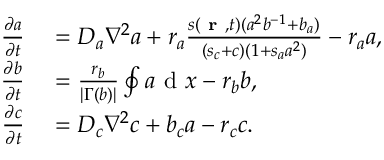<formula> <loc_0><loc_0><loc_500><loc_500>\begin{array} { r l } { \frac { \partial a } { \partial t } } & = D _ { a } \nabla ^ { 2 } a + r _ { a } \frac { s ( r , t ) ( a ^ { 2 } b ^ { - 1 } + b _ { a } ) } { ( s _ { c } + c ) ( 1 + s _ { a } a ^ { 2 } ) } - r _ { a } a , } \\ { \frac { \partial b } { \partial t } } & = \frac { r _ { b } } { | \Gamma ( b ) | } \oint a d x - r _ { b } b , } \\ { \frac { \partial c } { \partial t } } & = D _ { c } \nabla ^ { 2 } c + b _ { c } a - r _ { c } c . } \end{array}</formula> 